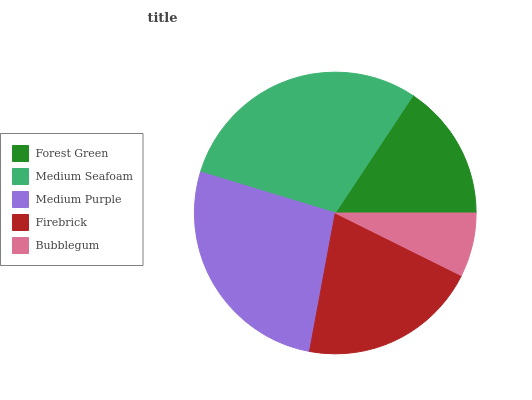Is Bubblegum the minimum?
Answer yes or no. Yes. Is Medium Seafoam the maximum?
Answer yes or no. Yes. Is Medium Purple the minimum?
Answer yes or no. No. Is Medium Purple the maximum?
Answer yes or no. No. Is Medium Seafoam greater than Medium Purple?
Answer yes or no. Yes. Is Medium Purple less than Medium Seafoam?
Answer yes or no. Yes. Is Medium Purple greater than Medium Seafoam?
Answer yes or no. No. Is Medium Seafoam less than Medium Purple?
Answer yes or no. No. Is Firebrick the high median?
Answer yes or no. Yes. Is Firebrick the low median?
Answer yes or no. Yes. Is Bubblegum the high median?
Answer yes or no. No. Is Bubblegum the low median?
Answer yes or no. No. 